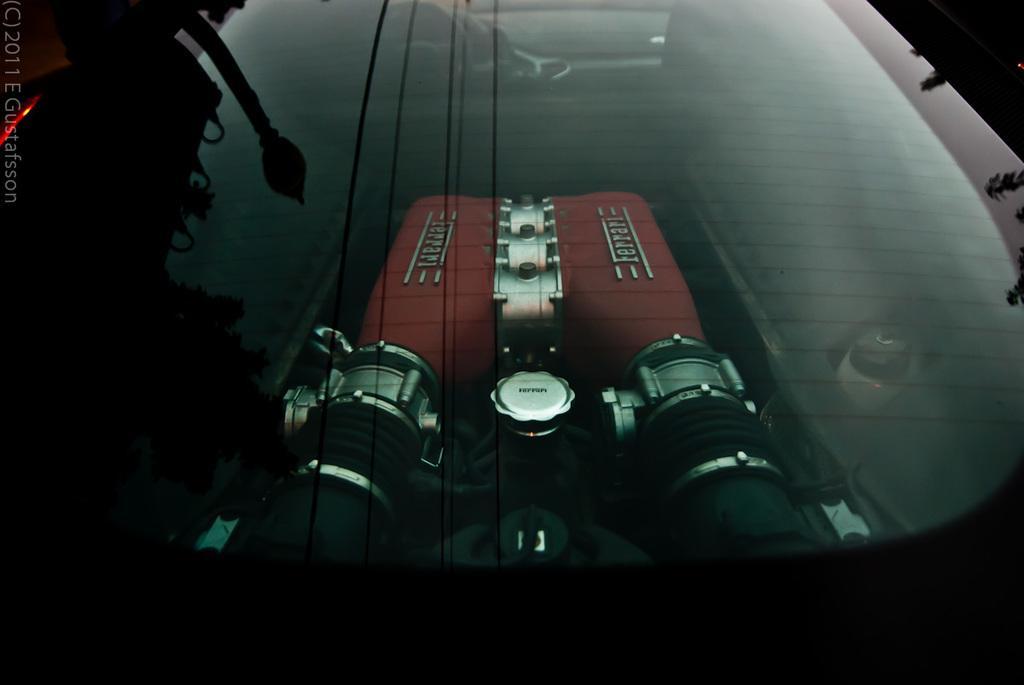How would you summarize this image in a sentence or two? In this picture we can see a glass. In this class we can see a machine. A watermark is visible on the left side. 